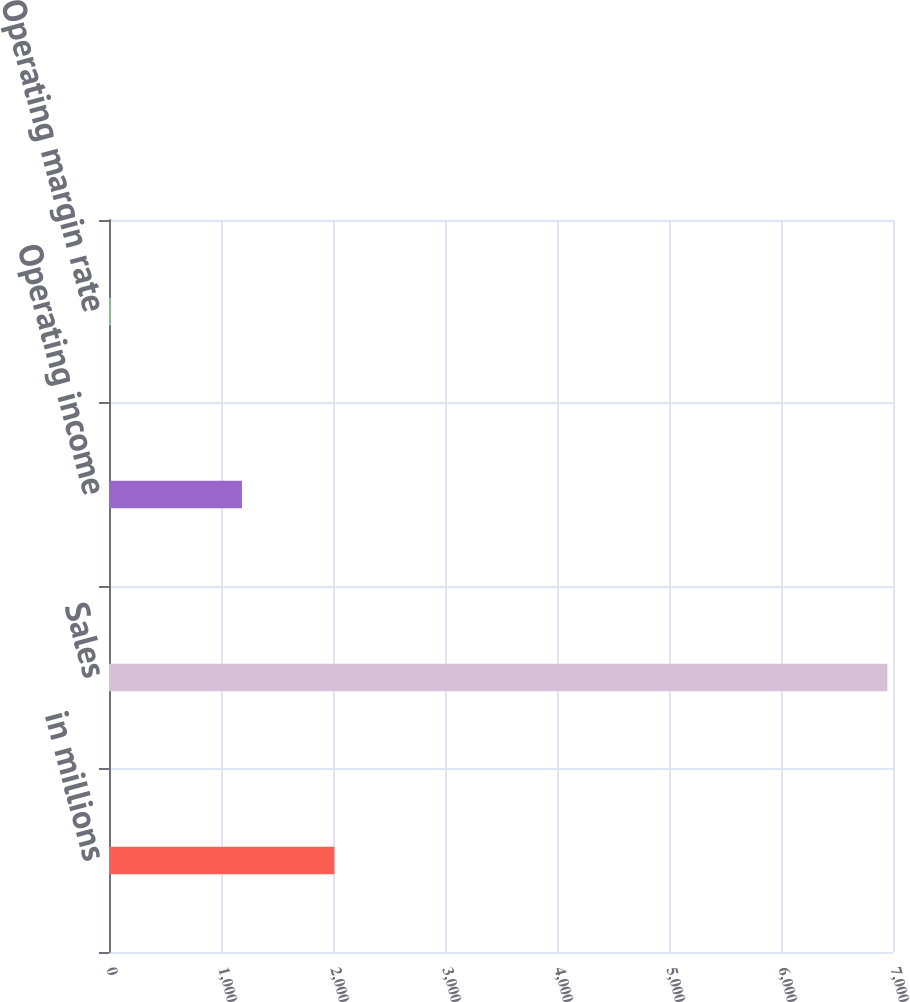<chart> <loc_0><loc_0><loc_500><loc_500><bar_chart><fcel>in millions<fcel>Sales<fcel>Operating income<fcel>Operating margin rate<nl><fcel>2012<fcel>6950<fcel>1187<fcel>17.1<nl></chart> 